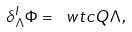Convert formula to latex. <formula><loc_0><loc_0><loc_500><loc_500>\delta _ { \Lambda } ^ { I } \Phi = \ w t c Q \Lambda ,</formula> 